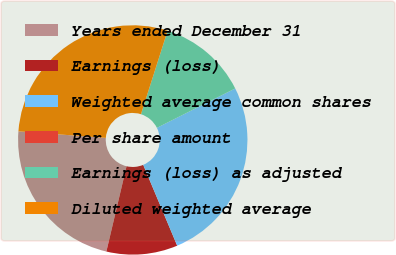Convert chart. <chart><loc_0><loc_0><loc_500><loc_500><pie_chart><fcel>Years ended December 31<fcel>Earnings (loss)<fcel>Weighted average common shares<fcel>Per share amount<fcel>Earnings (loss) as adjusted<fcel>Diluted weighted average<nl><fcel>22.5%<fcel>10.03%<fcel>26.08%<fcel>0.0%<fcel>12.67%<fcel>28.72%<nl></chart> 